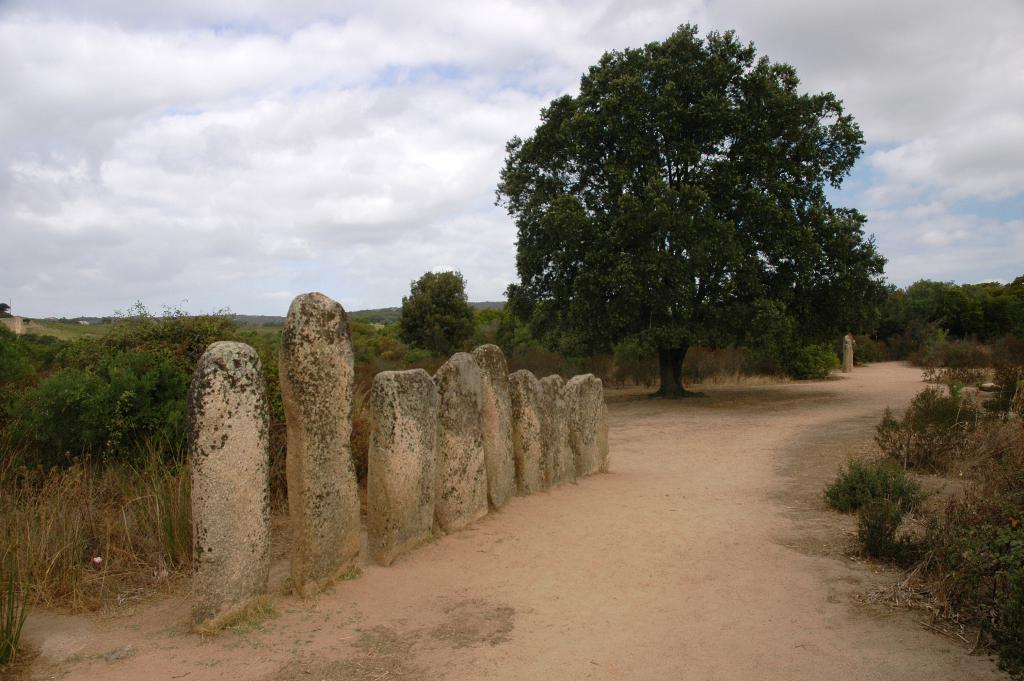What type of objects are on the road in the image? There are stones present on the road in the image. What can be seen in the background of the image? There are trees in the background of the image. How would you describe the sky in the image? The sky is cloudy in the image. What news is being reported on the bag in the image? There is no bag or news report present in the image. What day of the week is depicted in the image? The day of the week is not mentioned or depicted in the image. 